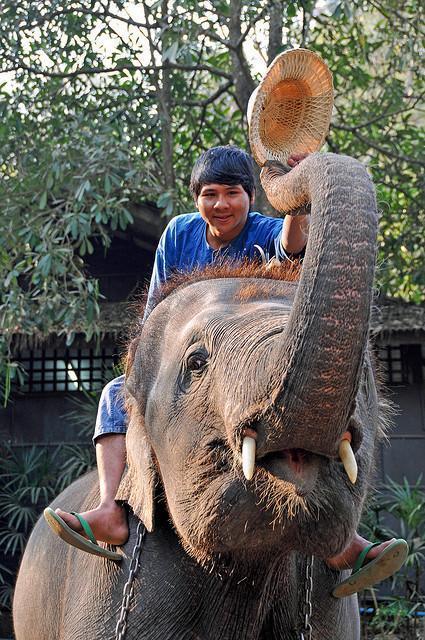How many people are there?
Give a very brief answer. 1. How many rolls of white toilet paper are in the bathroom?
Give a very brief answer. 0. 